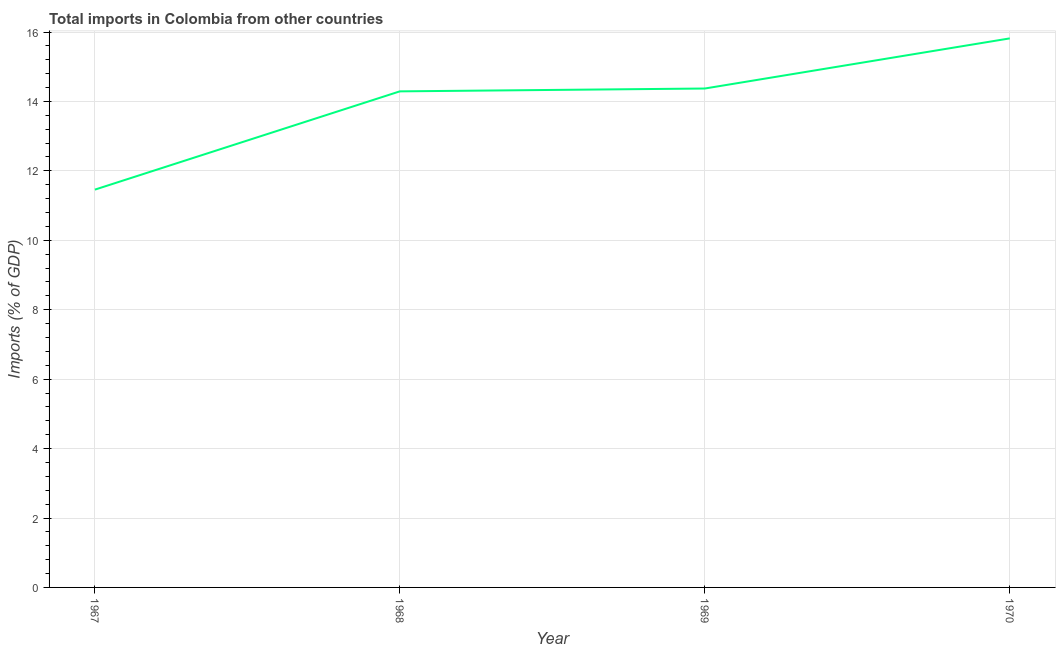What is the total imports in 1968?
Keep it short and to the point. 14.29. Across all years, what is the maximum total imports?
Give a very brief answer. 15.82. Across all years, what is the minimum total imports?
Ensure brevity in your answer.  11.46. In which year was the total imports maximum?
Ensure brevity in your answer.  1970. In which year was the total imports minimum?
Provide a short and direct response. 1967. What is the sum of the total imports?
Make the answer very short. 55.94. What is the difference between the total imports in 1967 and 1969?
Keep it short and to the point. -2.91. What is the average total imports per year?
Provide a short and direct response. 13.99. What is the median total imports?
Provide a succinct answer. 14.33. What is the ratio of the total imports in 1968 to that in 1969?
Your answer should be compact. 0.99. Is the difference between the total imports in 1967 and 1968 greater than the difference between any two years?
Offer a terse response. No. What is the difference between the highest and the second highest total imports?
Provide a succinct answer. 1.44. What is the difference between the highest and the lowest total imports?
Give a very brief answer. 4.36. Does the total imports monotonically increase over the years?
Give a very brief answer. Yes. What is the difference between two consecutive major ticks on the Y-axis?
Give a very brief answer. 2. Are the values on the major ticks of Y-axis written in scientific E-notation?
Keep it short and to the point. No. Does the graph contain any zero values?
Offer a very short reply. No. Does the graph contain grids?
Provide a succinct answer. Yes. What is the title of the graph?
Offer a very short reply. Total imports in Colombia from other countries. What is the label or title of the X-axis?
Provide a succinct answer. Year. What is the label or title of the Y-axis?
Offer a terse response. Imports (% of GDP). What is the Imports (% of GDP) in 1967?
Provide a short and direct response. 11.46. What is the Imports (% of GDP) in 1968?
Make the answer very short. 14.29. What is the Imports (% of GDP) in 1969?
Provide a short and direct response. 14.37. What is the Imports (% of GDP) in 1970?
Your answer should be compact. 15.82. What is the difference between the Imports (% of GDP) in 1967 and 1968?
Provide a succinct answer. -2.83. What is the difference between the Imports (% of GDP) in 1967 and 1969?
Provide a succinct answer. -2.91. What is the difference between the Imports (% of GDP) in 1967 and 1970?
Your answer should be very brief. -4.36. What is the difference between the Imports (% of GDP) in 1968 and 1969?
Keep it short and to the point. -0.08. What is the difference between the Imports (% of GDP) in 1968 and 1970?
Offer a very short reply. -1.53. What is the difference between the Imports (% of GDP) in 1969 and 1970?
Keep it short and to the point. -1.44. What is the ratio of the Imports (% of GDP) in 1967 to that in 1968?
Keep it short and to the point. 0.8. What is the ratio of the Imports (% of GDP) in 1967 to that in 1969?
Your response must be concise. 0.8. What is the ratio of the Imports (% of GDP) in 1967 to that in 1970?
Give a very brief answer. 0.72. What is the ratio of the Imports (% of GDP) in 1968 to that in 1970?
Keep it short and to the point. 0.9. What is the ratio of the Imports (% of GDP) in 1969 to that in 1970?
Offer a very short reply. 0.91. 